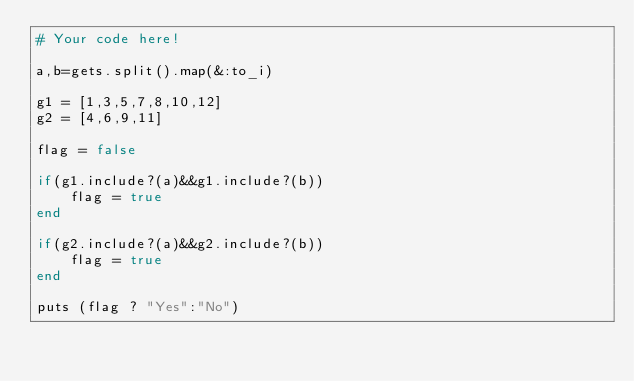Convert code to text. <code><loc_0><loc_0><loc_500><loc_500><_Ruby_># Your code here!

a,b=gets.split().map(&:to_i)

g1 = [1,3,5,7,8,10,12]
g2 = [4,6,9,11]

flag = false

if(g1.include?(a)&&g1.include?(b))
    flag = true
end

if(g2.include?(a)&&g2.include?(b))
    flag = true
end

puts (flag ? "Yes":"No")</code> 